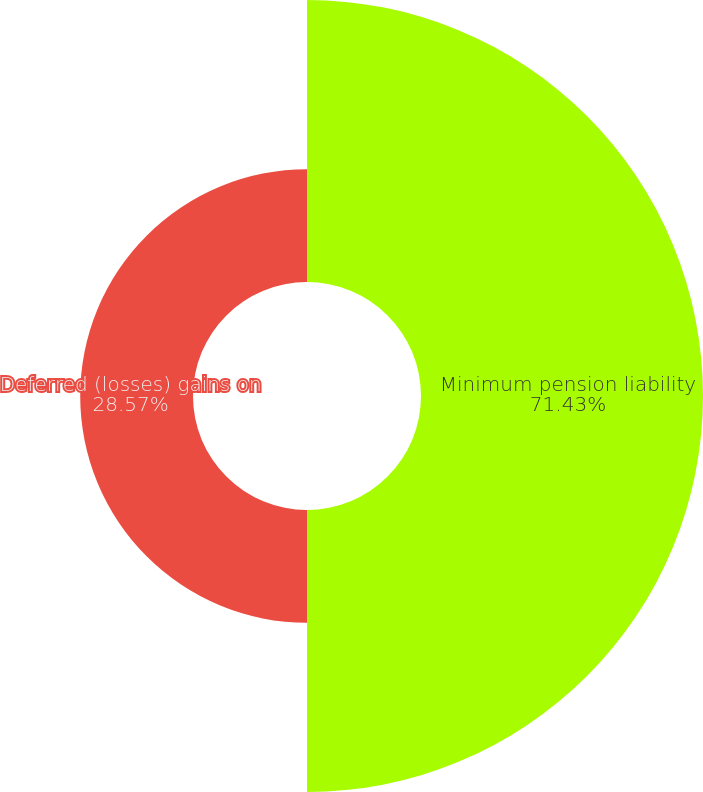Convert chart to OTSL. <chart><loc_0><loc_0><loc_500><loc_500><pie_chart><fcel>Minimum pension liability<fcel>Deferred (losses) gains on<nl><fcel>71.43%<fcel>28.57%<nl></chart> 